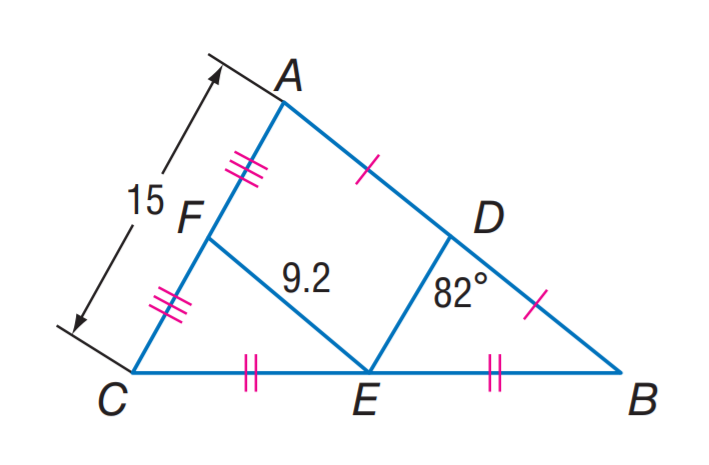Answer the mathemtical geometry problem and directly provide the correct option letter.
Question: Find m \angle F E D.
Choices: A: 8 B: 41 C: 49 D: 82 D 